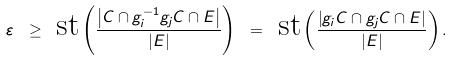Convert formula to latex. <formula><loc_0><loc_0><loc_500><loc_500>\varepsilon \ \geq \ \text {st} \left ( \frac { \left | C \cap g _ { i } ^ { - 1 } g _ { j } C \cap E \right | } { \left | E \right | } \right ) \ = \ \text {st} \left ( \frac { \left | g _ { i } C \cap g _ { j } C \cap E \right | } { \left | E \right | } \right ) .</formula> 